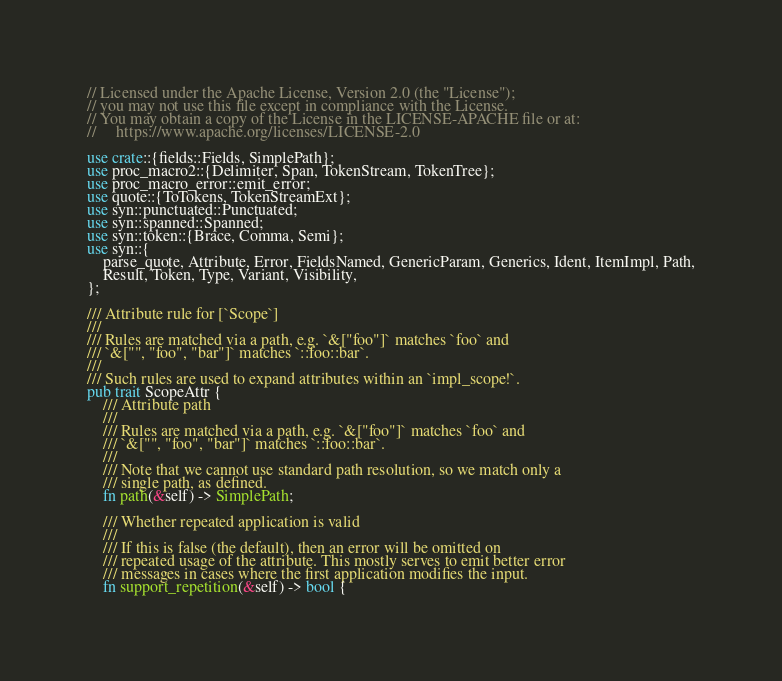<code> <loc_0><loc_0><loc_500><loc_500><_Rust_>// Licensed under the Apache License, Version 2.0 (the "License");
// you may not use this file except in compliance with the License.
// You may obtain a copy of the License in the LICENSE-APACHE file or at:
//     https://www.apache.org/licenses/LICENSE-2.0

use crate::{fields::Fields, SimplePath};
use proc_macro2::{Delimiter, Span, TokenStream, TokenTree};
use proc_macro_error::emit_error;
use quote::{ToTokens, TokenStreamExt};
use syn::punctuated::Punctuated;
use syn::spanned::Spanned;
use syn::token::{Brace, Comma, Semi};
use syn::{
    parse_quote, Attribute, Error, FieldsNamed, GenericParam, Generics, Ident, ItemImpl, Path,
    Result, Token, Type, Variant, Visibility,
};

/// Attribute rule for [`Scope`]
///
/// Rules are matched via a path, e.g. `&["foo"]` matches `foo` and
/// `&["", "foo", "bar"]` matches `::foo::bar`.
///
/// Such rules are used to expand attributes within an `impl_scope!`.
pub trait ScopeAttr {
    /// Attribute path
    ///
    /// Rules are matched via a path, e.g. `&["foo"]` matches `foo` and
    /// `&["", "foo", "bar"]` matches `::foo::bar`.
    ///
    /// Note that we cannot use standard path resolution, so we match only a
    /// single path, as defined.
    fn path(&self) -> SimplePath;

    /// Whether repeated application is valid
    ///
    /// If this is false (the default), then an error will be omitted on
    /// repeated usage of the attribute. This mostly serves to emit better error
    /// messages in cases where the first application modifies the input.
    fn support_repetition(&self) -> bool {</code> 